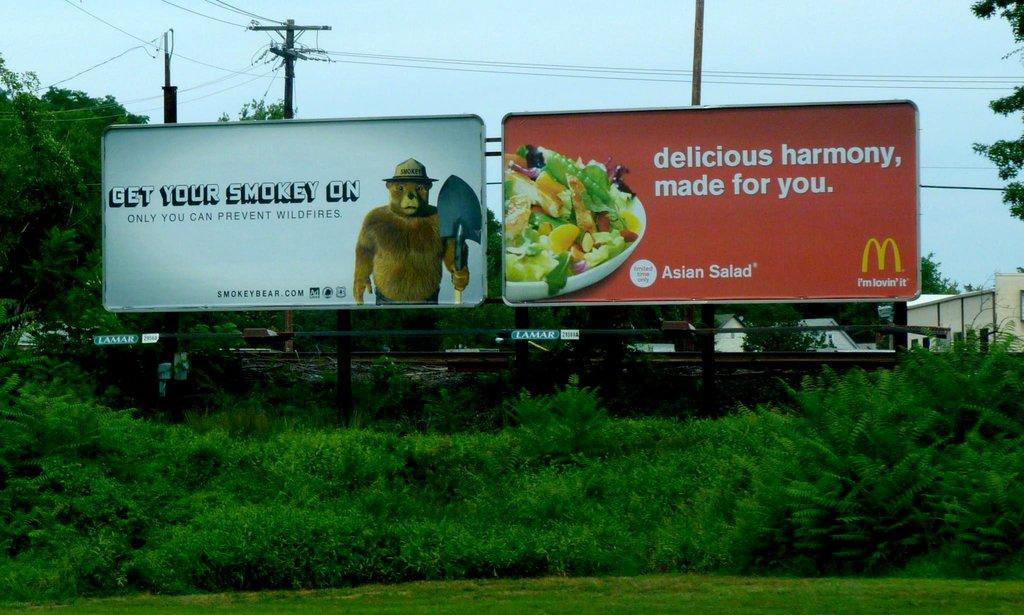<image>
Describe the image concisely. A McDonald's billboard for Asian Salads sitting next to a forest fire safety billboard. 